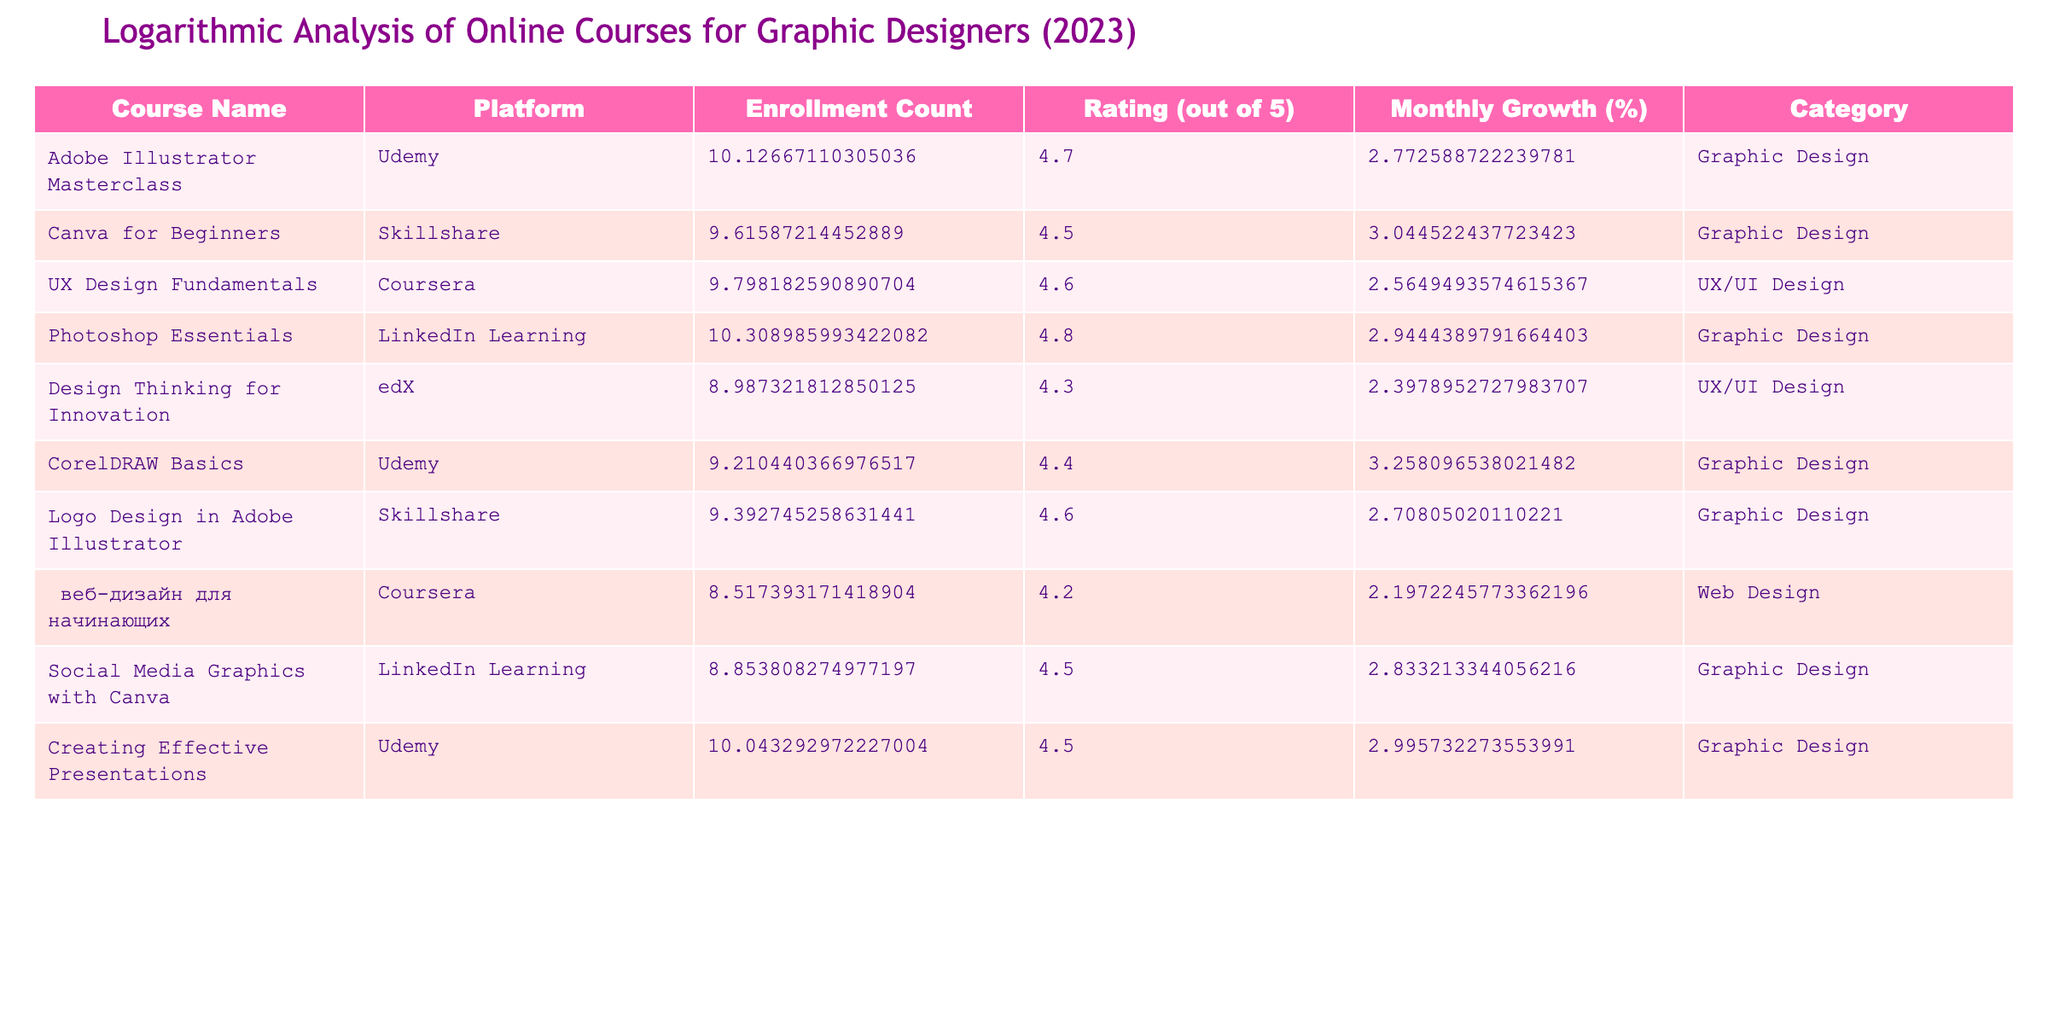What is the course with the highest enrollment count? By looking at the 'Enrollment Count' column, I can see that the course "Photoshop Essentials" has the highest value of 30000 enrollments.
Answer: Photoshop Essentials Which course has the lowest rating? The course "веб-дизайн для начинающих" has the lowest rating value in the 'Rating (out of 5)' column at 4.2.
Answer: веб-дизайн для начинающих What is the average enrollment count of all courses listed? To find the average enrollment count, I add the enrollment counts of all courses: (25000 + 15000 + 18000 + 30000 + 8000 + 10000 + 12000 + 5000 + 7000 + 23000) = 124000. There are 10 courses, so the average is 124000 / 10 = 12400.
Answer: 12400 Does the "CorelDRAW Basics" course have a higher monthly growth percentage than "Adobe Illustrator Masterclass"? The monthly growth percentage for "CorelDRAW Basics" is 25%, which is higher than 15% for "Adobe Illustrator Masterclass". Therefore, the statement is true.
Answer: Yes Which platform has a course that includes the term "Social Media" in its title, and what is its rating? The course titled "Social Media Graphics with Canva" is offered on the LinkedIn Learning platform and its rating is 4.5 based on the table.
Answer: LinkedIn Learning, 4.5 What is the difference in monthly growth percentage between the highest and lowest courses? The highest monthly growth percentage is for "CorelDRAW Basics" at 25%, and the lowest is for "веб-дизайн для начинающих" at 8%. The difference is 25% - 8% = 17%.
Answer: 17% How many courses have a rating higher than 4.5? By reviewing the 'Rating (out of 5)' column, I see that the courses "Adobe Illustrator Masterclass" (4.7), "Photoshop Essentials" (4.8), "UX Design Fundamentals" (4.6), "Logo Design in Adobe Illustrator" (4.6), and "Canva for Beginners" (4.5) qualify, making it 5 courses in total.
Answer: 5 Which graphic design course offers the lowest monthly growth percentage, and what is that percentage? The course "Design Thinking for Innovation" shows the lowest monthly growth percentage at 10%.
Answer: Design Thinking for Innovation, 10% How many platforms are represented in the table? The table lists courses from 5 distinct platforms: Udemy, Skillshare, Coursera, LinkedIn Learning, and edX. Hence, there are 5 platforms represented.
Answer: 5 